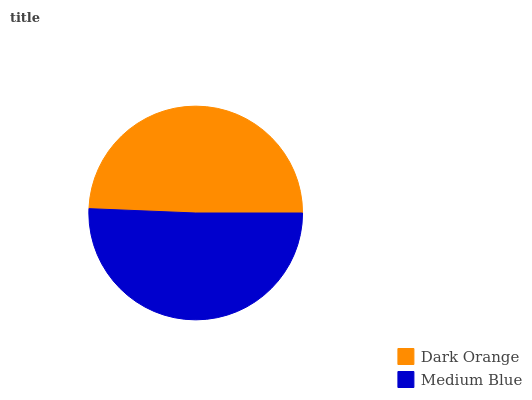Is Dark Orange the minimum?
Answer yes or no. Yes. Is Medium Blue the maximum?
Answer yes or no. Yes. Is Medium Blue the minimum?
Answer yes or no. No. Is Medium Blue greater than Dark Orange?
Answer yes or no. Yes. Is Dark Orange less than Medium Blue?
Answer yes or no. Yes. Is Dark Orange greater than Medium Blue?
Answer yes or no. No. Is Medium Blue less than Dark Orange?
Answer yes or no. No. Is Medium Blue the high median?
Answer yes or no. Yes. Is Dark Orange the low median?
Answer yes or no. Yes. Is Dark Orange the high median?
Answer yes or no. No. Is Medium Blue the low median?
Answer yes or no. No. 